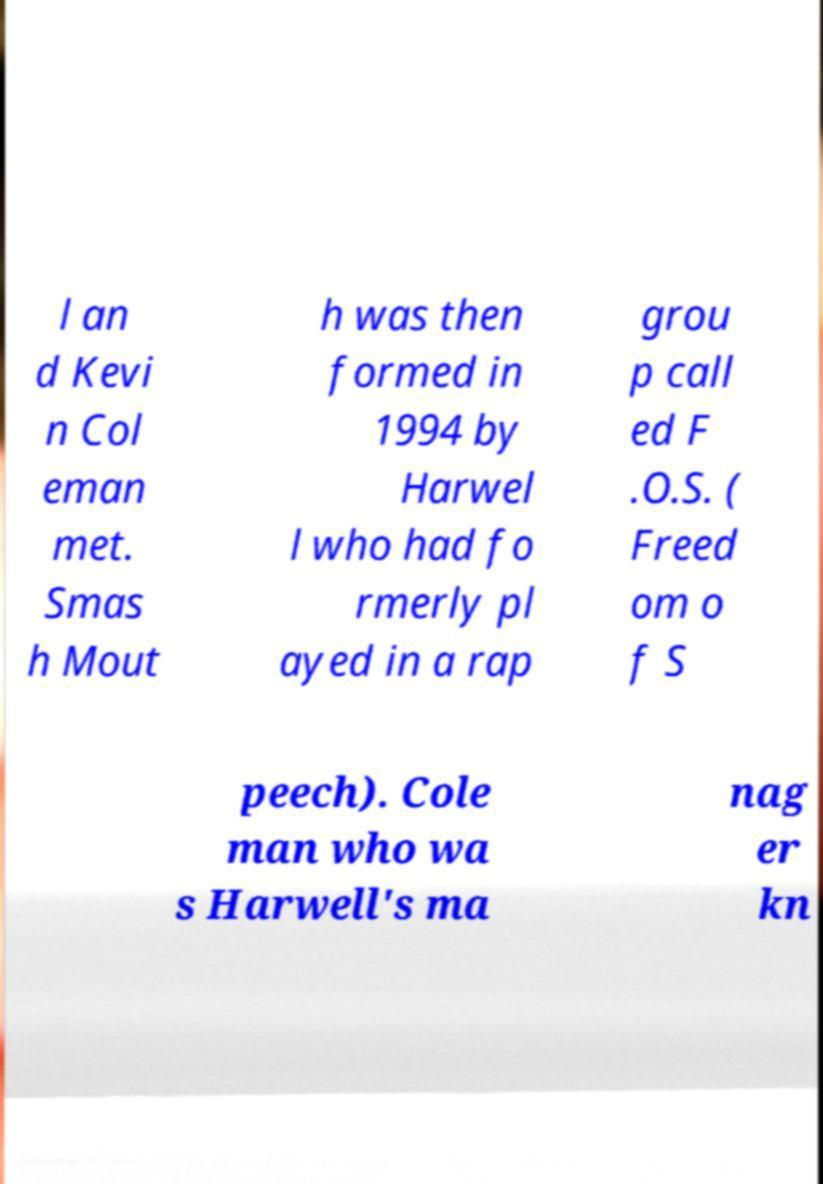Can you read and provide the text displayed in the image?This photo seems to have some interesting text. Can you extract and type it out for me? l an d Kevi n Col eman met. Smas h Mout h was then formed in 1994 by Harwel l who had fo rmerly pl ayed in a rap grou p call ed F .O.S. ( Freed om o f S peech). Cole man who wa s Harwell's ma nag er kn 